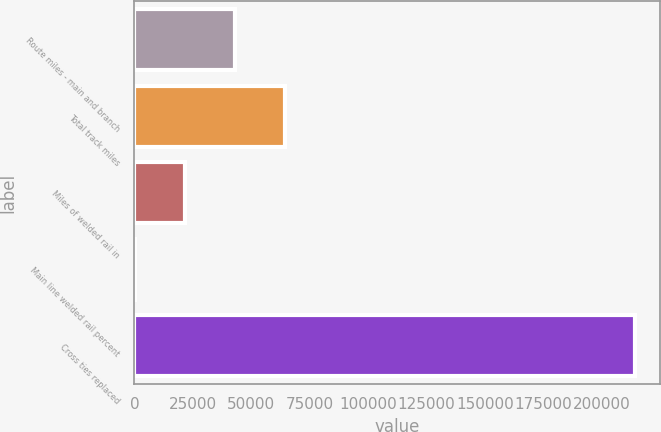Convert chart. <chart><loc_0><loc_0><loc_500><loc_500><bar_chart><fcel>Route miles - main and branch<fcel>Total track miles<fcel>Miles of welded rail in<fcel>Main line welded rail percent<fcel>Cross ties replaced<nl><fcel>42866.4<fcel>64260.6<fcel>21472.2<fcel>78<fcel>214020<nl></chart> 